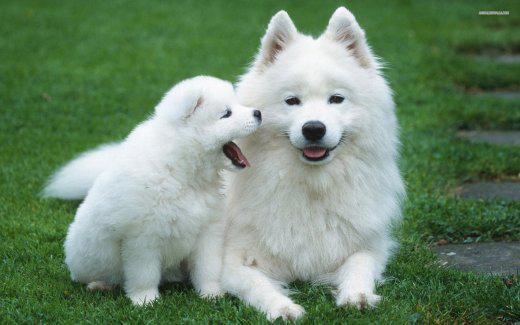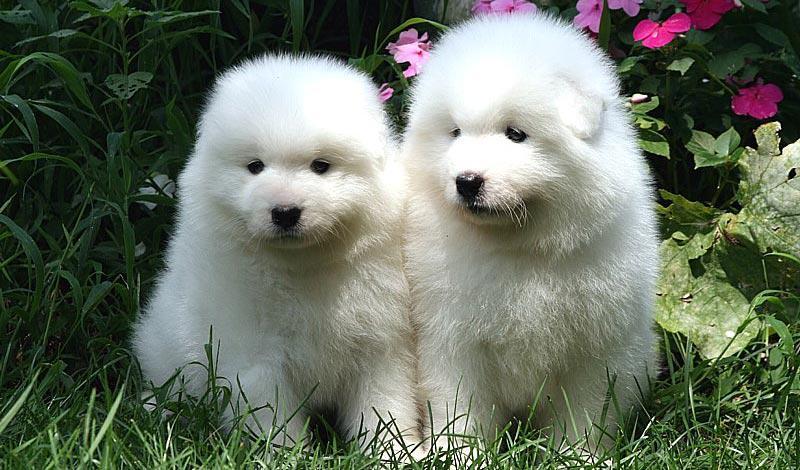The first image is the image on the left, the second image is the image on the right. Considering the images on both sides, is "There are two white dogs in each image that are roughly the same age." valid? Answer yes or no. No. The first image is the image on the left, the second image is the image on the right. Analyze the images presented: Is the assertion "Each image features two white dogs posed next to each other on green grass." valid? Answer yes or no. Yes. 